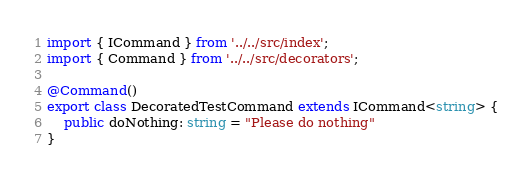Convert code to text. <code><loc_0><loc_0><loc_500><loc_500><_TypeScript_>import { ICommand } from '../../src/index';
import { Command } from '../../src/decorators';

@Command()
export class DecoratedTestCommand extends ICommand<string> {
    public doNothing: string = "Please do nothing"
}
</code> 